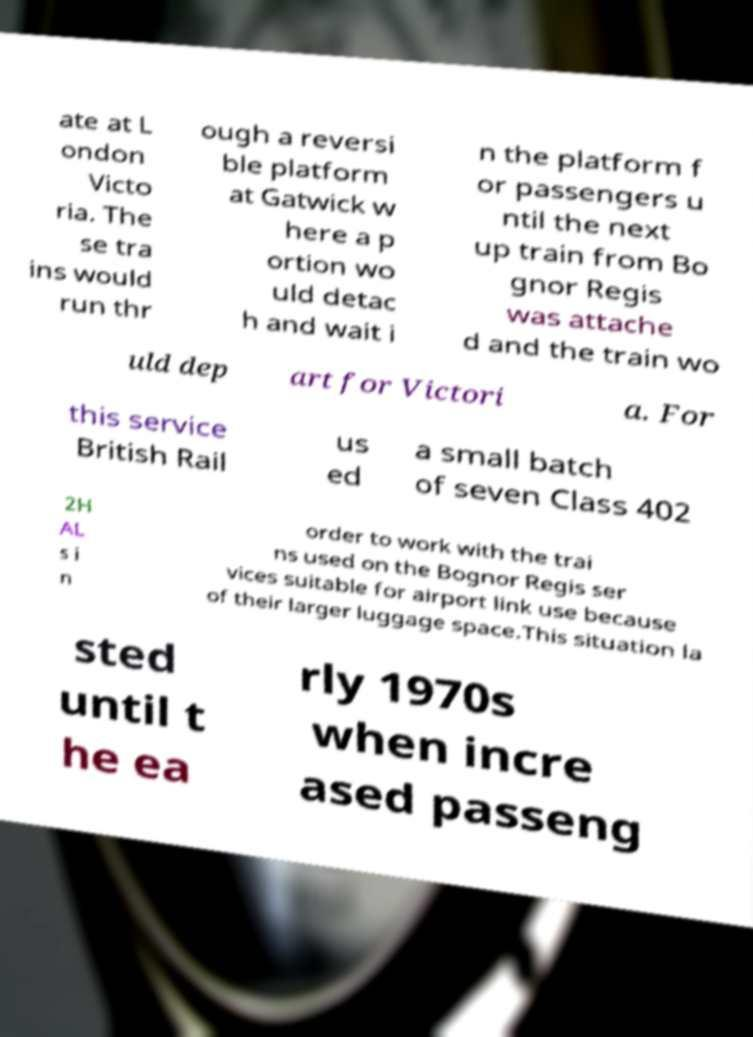Could you extract and type out the text from this image? ate at L ondon Victo ria. The se tra ins would run thr ough a reversi ble platform at Gatwick w here a p ortion wo uld detac h and wait i n the platform f or passengers u ntil the next up train from Bo gnor Regis was attache d and the train wo uld dep art for Victori a. For this service British Rail us ed a small batch of seven Class 402 2H AL s i n order to work with the trai ns used on the Bognor Regis ser vices suitable for airport link use because of their larger luggage space.This situation la sted until t he ea rly 1970s when incre ased passeng 